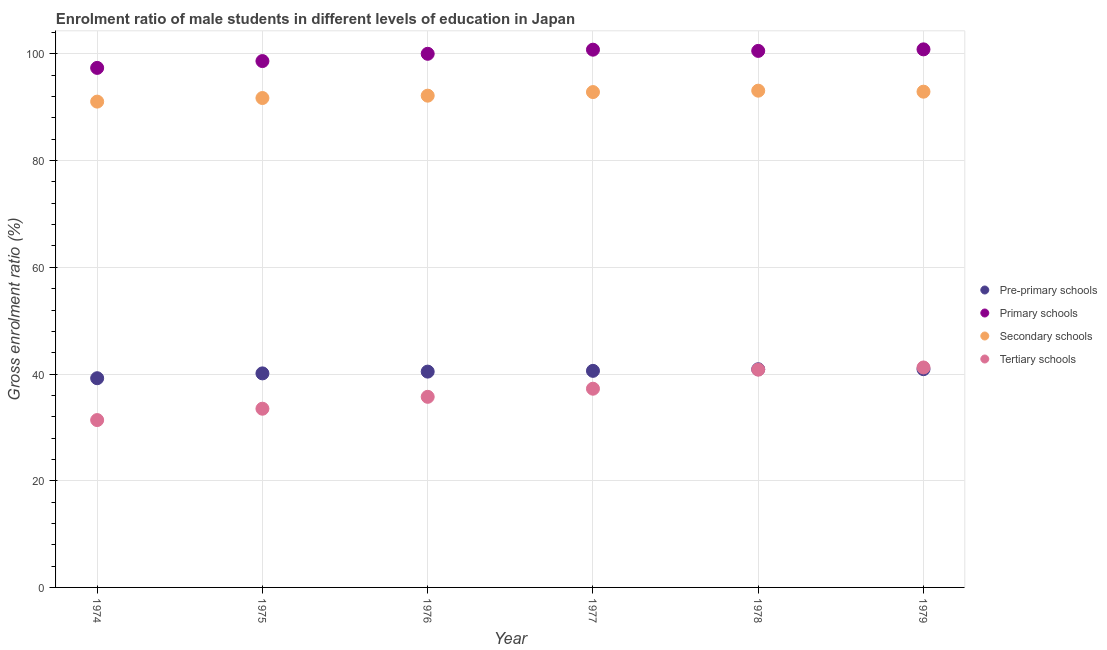Is the number of dotlines equal to the number of legend labels?
Your response must be concise. Yes. What is the gross enrolment ratio(female) in pre-primary schools in 1979?
Provide a succinct answer. 40.91. Across all years, what is the maximum gross enrolment ratio(female) in secondary schools?
Give a very brief answer. 93.11. Across all years, what is the minimum gross enrolment ratio(female) in pre-primary schools?
Make the answer very short. 39.21. In which year was the gross enrolment ratio(female) in secondary schools maximum?
Keep it short and to the point. 1978. In which year was the gross enrolment ratio(female) in tertiary schools minimum?
Provide a succinct answer. 1974. What is the total gross enrolment ratio(female) in tertiary schools in the graph?
Offer a terse response. 219.89. What is the difference between the gross enrolment ratio(female) in pre-primary schools in 1977 and that in 1978?
Keep it short and to the point. -0.3. What is the difference between the gross enrolment ratio(female) in primary schools in 1979 and the gross enrolment ratio(female) in tertiary schools in 1976?
Offer a terse response. 65.13. What is the average gross enrolment ratio(female) in primary schools per year?
Make the answer very short. 99.71. In the year 1977, what is the difference between the gross enrolment ratio(female) in pre-primary schools and gross enrolment ratio(female) in primary schools?
Your response must be concise. -60.2. What is the ratio of the gross enrolment ratio(female) in secondary schools in 1977 to that in 1978?
Provide a short and direct response. 1. Is the difference between the gross enrolment ratio(female) in secondary schools in 1976 and 1978 greater than the difference between the gross enrolment ratio(female) in pre-primary schools in 1976 and 1978?
Your answer should be compact. No. What is the difference between the highest and the second highest gross enrolment ratio(female) in primary schools?
Offer a terse response. 0.06. What is the difference between the highest and the lowest gross enrolment ratio(female) in tertiary schools?
Provide a succinct answer. 9.86. In how many years, is the gross enrolment ratio(female) in secondary schools greater than the average gross enrolment ratio(female) in secondary schools taken over all years?
Give a very brief answer. 3. Is it the case that in every year, the sum of the gross enrolment ratio(female) in tertiary schools and gross enrolment ratio(female) in pre-primary schools is greater than the sum of gross enrolment ratio(female) in primary schools and gross enrolment ratio(female) in secondary schools?
Ensure brevity in your answer.  No. Is it the case that in every year, the sum of the gross enrolment ratio(female) in pre-primary schools and gross enrolment ratio(female) in primary schools is greater than the gross enrolment ratio(female) in secondary schools?
Your answer should be compact. Yes. Is the gross enrolment ratio(female) in pre-primary schools strictly greater than the gross enrolment ratio(female) in primary schools over the years?
Your answer should be compact. No. Is the gross enrolment ratio(female) in pre-primary schools strictly less than the gross enrolment ratio(female) in tertiary schools over the years?
Your answer should be compact. No. How many years are there in the graph?
Your answer should be very brief. 6. What is the difference between two consecutive major ticks on the Y-axis?
Make the answer very short. 20. Are the values on the major ticks of Y-axis written in scientific E-notation?
Offer a terse response. No. Does the graph contain grids?
Provide a succinct answer. Yes. Where does the legend appear in the graph?
Make the answer very short. Center right. What is the title of the graph?
Your answer should be very brief. Enrolment ratio of male students in different levels of education in Japan. Does "Korea" appear as one of the legend labels in the graph?
Offer a very short reply. No. What is the Gross enrolment ratio (%) of Pre-primary schools in 1974?
Offer a terse response. 39.21. What is the Gross enrolment ratio (%) of Primary schools in 1974?
Provide a short and direct response. 97.38. What is the Gross enrolment ratio (%) of Secondary schools in 1974?
Give a very brief answer. 91.06. What is the Gross enrolment ratio (%) in Tertiary schools in 1974?
Offer a very short reply. 31.37. What is the Gross enrolment ratio (%) in Pre-primary schools in 1975?
Give a very brief answer. 40.12. What is the Gross enrolment ratio (%) of Primary schools in 1975?
Your answer should be compact. 98.66. What is the Gross enrolment ratio (%) in Secondary schools in 1975?
Offer a terse response. 91.73. What is the Gross enrolment ratio (%) in Tertiary schools in 1975?
Offer a very short reply. 33.5. What is the Gross enrolment ratio (%) of Pre-primary schools in 1976?
Provide a succinct answer. 40.45. What is the Gross enrolment ratio (%) of Primary schools in 1976?
Offer a terse response. 100.02. What is the Gross enrolment ratio (%) in Secondary schools in 1976?
Keep it short and to the point. 92.18. What is the Gross enrolment ratio (%) of Tertiary schools in 1976?
Keep it short and to the point. 35.73. What is the Gross enrolment ratio (%) of Pre-primary schools in 1977?
Give a very brief answer. 40.59. What is the Gross enrolment ratio (%) of Primary schools in 1977?
Your response must be concise. 100.8. What is the Gross enrolment ratio (%) of Secondary schools in 1977?
Make the answer very short. 92.85. What is the Gross enrolment ratio (%) in Tertiary schools in 1977?
Provide a short and direct response. 37.25. What is the Gross enrolment ratio (%) of Pre-primary schools in 1978?
Give a very brief answer. 40.89. What is the Gross enrolment ratio (%) in Primary schools in 1978?
Provide a short and direct response. 100.57. What is the Gross enrolment ratio (%) of Secondary schools in 1978?
Offer a very short reply. 93.11. What is the Gross enrolment ratio (%) in Tertiary schools in 1978?
Keep it short and to the point. 40.82. What is the Gross enrolment ratio (%) of Pre-primary schools in 1979?
Keep it short and to the point. 40.91. What is the Gross enrolment ratio (%) of Primary schools in 1979?
Offer a terse response. 100.86. What is the Gross enrolment ratio (%) of Secondary schools in 1979?
Your answer should be very brief. 92.92. What is the Gross enrolment ratio (%) of Tertiary schools in 1979?
Your answer should be very brief. 41.23. Across all years, what is the maximum Gross enrolment ratio (%) of Pre-primary schools?
Give a very brief answer. 40.91. Across all years, what is the maximum Gross enrolment ratio (%) in Primary schools?
Your answer should be compact. 100.86. Across all years, what is the maximum Gross enrolment ratio (%) of Secondary schools?
Your response must be concise. 93.11. Across all years, what is the maximum Gross enrolment ratio (%) in Tertiary schools?
Provide a succinct answer. 41.23. Across all years, what is the minimum Gross enrolment ratio (%) of Pre-primary schools?
Provide a succinct answer. 39.21. Across all years, what is the minimum Gross enrolment ratio (%) in Primary schools?
Give a very brief answer. 97.38. Across all years, what is the minimum Gross enrolment ratio (%) in Secondary schools?
Your answer should be compact. 91.06. Across all years, what is the minimum Gross enrolment ratio (%) in Tertiary schools?
Provide a succinct answer. 31.37. What is the total Gross enrolment ratio (%) in Pre-primary schools in the graph?
Provide a short and direct response. 242.18. What is the total Gross enrolment ratio (%) of Primary schools in the graph?
Offer a terse response. 598.28. What is the total Gross enrolment ratio (%) in Secondary schools in the graph?
Provide a short and direct response. 553.86. What is the total Gross enrolment ratio (%) in Tertiary schools in the graph?
Offer a terse response. 219.89. What is the difference between the Gross enrolment ratio (%) of Pre-primary schools in 1974 and that in 1975?
Offer a terse response. -0.91. What is the difference between the Gross enrolment ratio (%) of Primary schools in 1974 and that in 1975?
Make the answer very short. -1.28. What is the difference between the Gross enrolment ratio (%) of Secondary schools in 1974 and that in 1975?
Offer a very short reply. -0.67. What is the difference between the Gross enrolment ratio (%) of Tertiary schools in 1974 and that in 1975?
Make the answer very short. -2.13. What is the difference between the Gross enrolment ratio (%) of Pre-primary schools in 1974 and that in 1976?
Ensure brevity in your answer.  -1.24. What is the difference between the Gross enrolment ratio (%) in Primary schools in 1974 and that in 1976?
Your response must be concise. -2.64. What is the difference between the Gross enrolment ratio (%) in Secondary schools in 1974 and that in 1976?
Your answer should be very brief. -1.11. What is the difference between the Gross enrolment ratio (%) in Tertiary schools in 1974 and that in 1976?
Ensure brevity in your answer.  -4.36. What is the difference between the Gross enrolment ratio (%) of Pre-primary schools in 1974 and that in 1977?
Keep it short and to the point. -1.38. What is the difference between the Gross enrolment ratio (%) of Primary schools in 1974 and that in 1977?
Give a very brief answer. -3.41. What is the difference between the Gross enrolment ratio (%) of Secondary schools in 1974 and that in 1977?
Your answer should be compact. -1.79. What is the difference between the Gross enrolment ratio (%) of Tertiary schools in 1974 and that in 1977?
Provide a short and direct response. -5.88. What is the difference between the Gross enrolment ratio (%) in Pre-primary schools in 1974 and that in 1978?
Give a very brief answer. -1.68. What is the difference between the Gross enrolment ratio (%) of Primary schools in 1974 and that in 1978?
Your answer should be compact. -3.19. What is the difference between the Gross enrolment ratio (%) of Secondary schools in 1974 and that in 1978?
Give a very brief answer. -2.05. What is the difference between the Gross enrolment ratio (%) of Tertiary schools in 1974 and that in 1978?
Keep it short and to the point. -9.45. What is the difference between the Gross enrolment ratio (%) in Pre-primary schools in 1974 and that in 1979?
Give a very brief answer. -1.7. What is the difference between the Gross enrolment ratio (%) of Primary schools in 1974 and that in 1979?
Offer a very short reply. -3.47. What is the difference between the Gross enrolment ratio (%) in Secondary schools in 1974 and that in 1979?
Ensure brevity in your answer.  -1.86. What is the difference between the Gross enrolment ratio (%) in Tertiary schools in 1974 and that in 1979?
Offer a very short reply. -9.86. What is the difference between the Gross enrolment ratio (%) of Primary schools in 1975 and that in 1976?
Offer a terse response. -1.36. What is the difference between the Gross enrolment ratio (%) in Secondary schools in 1975 and that in 1976?
Your answer should be very brief. -0.44. What is the difference between the Gross enrolment ratio (%) of Tertiary schools in 1975 and that in 1976?
Provide a succinct answer. -2.23. What is the difference between the Gross enrolment ratio (%) of Pre-primary schools in 1975 and that in 1977?
Make the answer very short. -0.47. What is the difference between the Gross enrolment ratio (%) of Primary schools in 1975 and that in 1977?
Offer a very short reply. -2.14. What is the difference between the Gross enrolment ratio (%) in Secondary schools in 1975 and that in 1977?
Your answer should be very brief. -1.12. What is the difference between the Gross enrolment ratio (%) of Tertiary schools in 1975 and that in 1977?
Make the answer very short. -3.75. What is the difference between the Gross enrolment ratio (%) in Pre-primary schools in 1975 and that in 1978?
Your answer should be very brief. -0.77. What is the difference between the Gross enrolment ratio (%) in Primary schools in 1975 and that in 1978?
Make the answer very short. -1.91. What is the difference between the Gross enrolment ratio (%) in Secondary schools in 1975 and that in 1978?
Provide a short and direct response. -1.38. What is the difference between the Gross enrolment ratio (%) of Tertiary schools in 1975 and that in 1978?
Offer a terse response. -7.32. What is the difference between the Gross enrolment ratio (%) of Pre-primary schools in 1975 and that in 1979?
Your answer should be compact. -0.79. What is the difference between the Gross enrolment ratio (%) in Primary schools in 1975 and that in 1979?
Offer a very short reply. -2.2. What is the difference between the Gross enrolment ratio (%) of Secondary schools in 1975 and that in 1979?
Your answer should be very brief. -1.19. What is the difference between the Gross enrolment ratio (%) of Tertiary schools in 1975 and that in 1979?
Offer a terse response. -7.73. What is the difference between the Gross enrolment ratio (%) of Pre-primary schools in 1976 and that in 1977?
Offer a very short reply. -0.14. What is the difference between the Gross enrolment ratio (%) in Primary schools in 1976 and that in 1977?
Give a very brief answer. -0.77. What is the difference between the Gross enrolment ratio (%) of Secondary schools in 1976 and that in 1977?
Your answer should be very brief. -0.67. What is the difference between the Gross enrolment ratio (%) in Tertiary schools in 1976 and that in 1977?
Your answer should be compact. -1.52. What is the difference between the Gross enrolment ratio (%) in Pre-primary schools in 1976 and that in 1978?
Provide a short and direct response. -0.44. What is the difference between the Gross enrolment ratio (%) in Primary schools in 1976 and that in 1978?
Ensure brevity in your answer.  -0.54. What is the difference between the Gross enrolment ratio (%) of Secondary schools in 1976 and that in 1978?
Provide a short and direct response. -0.94. What is the difference between the Gross enrolment ratio (%) in Tertiary schools in 1976 and that in 1978?
Your answer should be compact. -5.09. What is the difference between the Gross enrolment ratio (%) of Pre-primary schools in 1976 and that in 1979?
Your response must be concise. -0.46. What is the difference between the Gross enrolment ratio (%) in Primary schools in 1976 and that in 1979?
Offer a very short reply. -0.83. What is the difference between the Gross enrolment ratio (%) in Secondary schools in 1976 and that in 1979?
Keep it short and to the point. -0.75. What is the difference between the Gross enrolment ratio (%) of Tertiary schools in 1976 and that in 1979?
Provide a short and direct response. -5.5. What is the difference between the Gross enrolment ratio (%) of Pre-primary schools in 1977 and that in 1978?
Your response must be concise. -0.3. What is the difference between the Gross enrolment ratio (%) of Primary schools in 1977 and that in 1978?
Keep it short and to the point. 0.23. What is the difference between the Gross enrolment ratio (%) in Secondary schools in 1977 and that in 1978?
Offer a terse response. -0.26. What is the difference between the Gross enrolment ratio (%) in Tertiary schools in 1977 and that in 1978?
Make the answer very short. -3.57. What is the difference between the Gross enrolment ratio (%) of Pre-primary schools in 1977 and that in 1979?
Offer a very short reply. -0.32. What is the difference between the Gross enrolment ratio (%) of Primary schools in 1977 and that in 1979?
Your answer should be very brief. -0.06. What is the difference between the Gross enrolment ratio (%) of Secondary schools in 1977 and that in 1979?
Your answer should be compact. -0.07. What is the difference between the Gross enrolment ratio (%) of Tertiary schools in 1977 and that in 1979?
Keep it short and to the point. -3.98. What is the difference between the Gross enrolment ratio (%) in Pre-primary schools in 1978 and that in 1979?
Ensure brevity in your answer.  -0.02. What is the difference between the Gross enrolment ratio (%) in Primary schools in 1978 and that in 1979?
Your response must be concise. -0.29. What is the difference between the Gross enrolment ratio (%) in Secondary schools in 1978 and that in 1979?
Ensure brevity in your answer.  0.19. What is the difference between the Gross enrolment ratio (%) of Tertiary schools in 1978 and that in 1979?
Your response must be concise. -0.41. What is the difference between the Gross enrolment ratio (%) in Pre-primary schools in 1974 and the Gross enrolment ratio (%) in Primary schools in 1975?
Your answer should be compact. -59.45. What is the difference between the Gross enrolment ratio (%) in Pre-primary schools in 1974 and the Gross enrolment ratio (%) in Secondary schools in 1975?
Provide a short and direct response. -52.52. What is the difference between the Gross enrolment ratio (%) of Pre-primary schools in 1974 and the Gross enrolment ratio (%) of Tertiary schools in 1975?
Give a very brief answer. 5.72. What is the difference between the Gross enrolment ratio (%) in Primary schools in 1974 and the Gross enrolment ratio (%) in Secondary schools in 1975?
Ensure brevity in your answer.  5.65. What is the difference between the Gross enrolment ratio (%) in Primary schools in 1974 and the Gross enrolment ratio (%) in Tertiary schools in 1975?
Provide a short and direct response. 63.88. What is the difference between the Gross enrolment ratio (%) of Secondary schools in 1974 and the Gross enrolment ratio (%) of Tertiary schools in 1975?
Your response must be concise. 57.56. What is the difference between the Gross enrolment ratio (%) in Pre-primary schools in 1974 and the Gross enrolment ratio (%) in Primary schools in 1976?
Your answer should be very brief. -60.81. What is the difference between the Gross enrolment ratio (%) in Pre-primary schools in 1974 and the Gross enrolment ratio (%) in Secondary schools in 1976?
Keep it short and to the point. -52.96. What is the difference between the Gross enrolment ratio (%) of Pre-primary schools in 1974 and the Gross enrolment ratio (%) of Tertiary schools in 1976?
Your response must be concise. 3.49. What is the difference between the Gross enrolment ratio (%) of Primary schools in 1974 and the Gross enrolment ratio (%) of Secondary schools in 1976?
Make the answer very short. 5.21. What is the difference between the Gross enrolment ratio (%) of Primary schools in 1974 and the Gross enrolment ratio (%) of Tertiary schools in 1976?
Offer a very short reply. 61.65. What is the difference between the Gross enrolment ratio (%) in Secondary schools in 1974 and the Gross enrolment ratio (%) in Tertiary schools in 1976?
Offer a very short reply. 55.33. What is the difference between the Gross enrolment ratio (%) of Pre-primary schools in 1974 and the Gross enrolment ratio (%) of Primary schools in 1977?
Your answer should be compact. -61.58. What is the difference between the Gross enrolment ratio (%) in Pre-primary schools in 1974 and the Gross enrolment ratio (%) in Secondary schools in 1977?
Keep it short and to the point. -53.64. What is the difference between the Gross enrolment ratio (%) in Pre-primary schools in 1974 and the Gross enrolment ratio (%) in Tertiary schools in 1977?
Your answer should be very brief. 1.97. What is the difference between the Gross enrolment ratio (%) of Primary schools in 1974 and the Gross enrolment ratio (%) of Secondary schools in 1977?
Offer a terse response. 4.53. What is the difference between the Gross enrolment ratio (%) of Primary schools in 1974 and the Gross enrolment ratio (%) of Tertiary schools in 1977?
Provide a succinct answer. 60.13. What is the difference between the Gross enrolment ratio (%) in Secondary schools in 1974 and the Gross enrolment ratio (%) in Tertiary schools in 1977?
Your answer should be very brief. 53.81. What is the difference between the Gross enrolment ratio (%) of Pre-primary schools in 1974 and the Gross enrolment ratio (%) of Primary schools in 1978?
Your response must be concise. -61.35. What is the difference between the Gross enrolment ratio (%) in Pre-primary schools in 1974 and the Gross enrolment ratio (%) in Secondary schools in 1978?
Offer a terse response. -53.9. What is the difference between the Gross enrolment ratio (%) of Pre-primary schools in 1974 and the Gross enrolment ratio (%) of Tertiary schools in 1978?
Make the answer very short. -1.61. What is the difference between the Gross enrolment ratio (%) in Primary schools in 1974 and the Gross enrolment ratio (%) in Secondary schools in 1978?
Provide a short and direct response. 4.27. What is the difference between the Gross enrolment ratio (%) in Primary schools in 1974 and the Gross enrolment ratio (%) in Tertiary schools in 1978?
Provide a short and direct response. 56.56. What is the difference between the Gross enrolment ratio (%) of Secondary schools in 1974 and the Gross enrolment ratio (%) of Tertiary schools in 1978?
Provide a short and direct response. 50.24. What is the difference between the Gross enrolment ratio (%) of Pre-primary schools in 1974 and the Gross enrolment ratio (%) of Primary schools in 1979?
Offer a very short reply. -61.64. What is the difference between the Gross enrolment ratio (%) in Pre-primary schools in 1974 and the Gross enrolment ratio (%) in Secondary schools in 1979?
Provide a short and direct response. -53.71. What is the difference between the Gross enrolment ratio (%) in Pre-primary schools in 1974 and the Gross enrolment ratio (%) in Tertiary schools in 1979?
Provide a succinct answer. -2.01. What is the difference between the Gross enrolment ratio (%) in Primary schools in 1974 and the Gross enrolment ratio (%) in Secondary schools in 1979?
Ensure brevity in your answer.  4.46. What is the difference between the Gross enrolment ratio (%) in Primary schools in 1974 and the Gross enrolment ratio (%) in Tertiary schools in 1979?
Your response must be concise. 56.15. What is the difference between the Gross enrolment ratio (%) in Secondary schools in 1974 and the Gross enrolment ratio (%) in Tertiary schools in 1979?
Keep it short and to the point. 49.83. What is the difference between the Gross enrolment ratio (%) in Pre-primary schools in 1975 and the Gross enrolment ratio (%) in Primary schools in 1976?
Your answer should be very brief. -59.9. What is the difference between the Gross enrolment ratio (%) of Pre-primary schools in 1975 and the Gross enrolment ratio (%) of Secondary schools in 1976?
Your response must be concise. -52.06. What is the difference between the Gross enrolment ratio (%) of Pre-primary schools in 1975 and the Gross enrolment ratio (%) of Tertiary schools in 1976?
Your response must be concise. 4.39. What is the difference between the Gross enrolment ratio (%) in Primary schools in 1975 and the Gross enrolment ratio (%) in Secondary schools in 1976?
Provide a short and direct response. 6.48. What is the difference between the Gross enrolment ratio (%) of Primary schools in 1975 and the Gross enrolment ratio (%) of Tertiary schools in 1976?
Your response must be concise. 62.93. What is the difference between the Gross enrolment ratio (%) of Secondary schools in 1975 and the Gross enrolment ratio (%) of Tertiary schools in 1976?
Provide a short and direct response. 56.01. What is the difference between the Gross enrolment ratio (%) of Pre-primary schools in 1975 and the Gross enrolment ratio (%) of Primary schools in 1977?
Keep it short and to the point. -60.68. What is the difference between the Gross enrolment ratio (%) in Pre-primary schools in 1975 and the Gross enrolment ratio (%) in Secondary schools in 1977?
Provide a short and direct response. -52.73. What is the difference between the Gross enrolment ratio (%) in Pre-primary schools in 1975 and the Gross enrolment ratio (%) in Tertiary schools in 1977?
Keep it short and to the point. 2.87. What is the difference between the Gross enrolment ratio (%) in Primary schools in 1975 and the Gross enrolment ratio (%) in Secondary schools in 1977?
Give a very brief answer. 5.81. What is the difference between the Gross enrolment ratio (%) of Primary schools in 1975 and the Gross enrolment ratio (%) of Tertiary schools in 1977?
Give a very brief answer. 61.41. What is the difference between the Gross enrolment ratio (%) of Secondary schools in 1975 and the Gross enrolment ratio (%) of Tertiary schools in 1977?
Offer a terse response. 54.49. What is the difference between the Gross enrolment ratio (%) in Pre-primary schools in 1975 and the Gross enrolment ratio (%) in Primary schools in 1978?
Make the answer very short. -60.45. What is the difference between the Gross enrolment ratio (%) in Pre-primary schools in 1975 and the Gross enrolment ratio (%) in Secondary schools in 1978?
Offer a terse response. -52.99. What is the difference between the Gross enrolment ratio (%) in Pre-primary schools in 1975 and the Gross enrolment ratio (%) in Tertiary schools in 1978?
Ensure brevity in your answer.  -0.7. What is the difference between the Gross enrolment ratio (%) of Primary schools in 1975 and the Gross enrolment ratio (%) of Secondary schools in 1978?
Offer a terse response. 5.55. What is the difference between the Gross enrolment ratio (%) in Primary schools in 1975 and the Gross enrolment ratio (%) in Tertiary schools in 1978?
Provide a succinct answer. 57.84. What is the difference between the Gross enrolment ratio (%) of Secondary schools in 1975 and the Gross enrolment ratio (%) of Tertiary schools in 1978?
Provide a short and direct response. 50.91. What is the difference between the Gross enrolment ratio (%) of Pre-primary schools in 1975 and the Gross enrolment ratio (%) of Primary schools in 1979?
Keep it short and to the point. -60.74. What is the difference between the Gross enrolment ratio (%) in Pre-primary schools in 1975 and the Gross enrolment ratio (%) in Secondary schools in 1979?
Provide a short and direct response. -52.81. What is the difference between the Gross enrolment ratio (%) of Pre-primary schools in 1975 and the Gross enrolment ratio (%) of Tertiary schools in 1979?
Your answer should be compact. -1.11. What is the difference between the Gross enrolment ratio (%) in Primary schools in 1975 and the Gross enrolment ratio (%) in Secondary schools in 1979?
Keep it short and to the point. 5.74. What is the difference between the Gross enrolment ratio (%) of Primary schools in 1975 and the Gross enrolment ratio (%) of Tertiary schools in 1979?
Make the answer very short. 57.43. What is the difference between the Gross enrolment ratio (%) of Secondary schools in 1975 and the Gross enrolment ratio (%) of Tertiary schools in 1979?
Your answer should be compact. 50.51. What is the difference between the Gross enrolment ratio (%) in Pre-primary schools in 1976 and the Gross enrolment ratio (%) in Primary schools in 1977?
Offer a terse response. -60.34. What is the difference between the Gross enrolment ratio (%) in Pre-primary schools in 1976 and the Gross enrolment ratio (%) in Secondary schools in 1977?
Your answer should be compact. -52.4. What is the difference between the Gross enrolment ratio (%) in Pre-primary schools in 1976 and the Gross enrolment ratio (%) in Tertiary schools in 1977?
Offer a very short reply. 3.21. What is the difference between the Gross enrolment ratio (%) in Primary schools in 1976 and the Gross enrolment ratio (%) in Secondary schools in 1977?
Ensure brevity in your answer.  7.17. What is the difference between the Gross enrolment ratio (%) in Primary schools in 1976 and the Gross enrolment ratio (%) in Tertiary schools in 1977?
Your answer should be very brief. 62.78. What is the difference between the Gross enrolment ratio (%) of Secondary schools in 1976 and the Gross enrolment ratio (%) of Tertiary schools in 1977?
Your answer should be very brief. 54.93. What is the difference between the Gross enrolment ratio (%) of Pre-primary schools in 1976 and the Gross enrolment ratio (%) of Primary schools in 1978?
Make the answer very short. -60.11. What is the difference between the Gross enrolment ratio (%) in Pre-primary schools in 1976 and the Gross enrolment ratio (%) in Secondary schools in 1978?
Provide a short and direct response. -52.66. What is the difference between the Gross enrolment ratio (%) in Pre-primary schools in 1976 and the Gross enrolment ratio (%) in Tertiary schools in 1978?
Make the answer very short. -0.37. What is the difference between the Gross enrolment ratio (%) in Primary schools in 1976 and the Gross enrolment ratio (%) in Secondary schools in 1978?
Provide a short and direct response. 6.91. What is the difference between the Gross enrolment ratio (%) in Primary schools in 1976 and the Gross enrolment ratio (%) in Tertiary schools in 1978?
Your answer should be very brief. 59.2. What is the difference between the Gross enrolment ratio (%) of Secondary schools in 1976 and the Gross enrolment ratio (%) of Tertiary schools in 1978?
Ensure brevity in your answer.  51.35. What is the difference between the Gross enrolment ratio (%) of Pre-primary schools in 1976 and the Gross enrolment ratio (%) of Primary schools in 1979?
Keep it short and to the point. -60.4. What is the difference between the Gross enrolment ratio (%) in Pre-primary schools in 1976 and the Gross enrolment ratio (%) in Secondary schools in 1979?
Provide a succinct answer. -52.47. What is the difference between the Gross enrolment ratio (%) of Pre-primary schools in 1976 and the Gross enrolment ratio (%) of Tertiary schools in 1979?
Offer a terse response. -0.77. What is the difference between the Gross enrolment ratio (%) in Primary schools in 1976 and the Gross enrolment ratio (%) in Secondary schools in 1979?
Give a very brief answer. 7.1. What is the difference between the Gross enrolment ratio (%) of Primary schools in 1976 and the Gross enrolment ratio (%) of Tertiary schools in 1979?
Provide a short and direct response. 58.8. What is the difference between the Gross enrolment ratio (%) of Secondary schools in 1976 and the Gross enrolment ratio (%) of Tertiary schools in 1979?
Offer a terse response. 50.95. What is the difference between the Gross enrolment ratio (%) in Pre-primary schools in 1977 and the Gross enrolment ratio (%) in Primary schools in 1978?
Provide a short and direct response. -59.97. What is the difference between the Gross enrolment ratio (%) in Pre-primary schools in 1977 and the Gross enrolment ratio (%) in Secondary schools in 1978?
Your answer should be compact. -52.52. What is the difference between the Gross enrolment ratio (%) of Pre-primary schools in 1977 and the Gross enrolment ratio (%) of Tertiary schools in 1978?
Your answer should be very brief. -0.23. What is the difference between the Gross enrolment ratio (%) of Primary schools in 1977 and the Gross enrolment ratio (%) of Secondary schools in 1978?
Keep it short and to the point. 7.68. What is the difference between the Gross enrolment ratio (%) of Primary schools in 1977 and the Gross enrolment ratio (%) of Tertiary schools in 1978?
Your response must be concise. 59.97. What is the difference between the Gross enrolment ratio (%) of Secondary schools in 1977 and the Gross enrolment ratio (%) of Tertiary schools in 1978?
Give a very brief answer. 52.03. What is the difference between the Gross enrolment ratio (%) of Pre-primary schools in 1977 and the Gross enrolment ratio (%) of Primary schools in 1979?
Provide a short and direct response. -60.26. What is the difference between the Gross enrolment ratio (%) of Pre-primary schools in 1977 and the Gross enrolment ratio (%) of Secondary schools in 1979?
Your response must be concise. -52.33. What is the difference between the Gross enrolment ratio (%) of Pre-primary schools in 1977 and the Gross enrolment ratio (%) of Tertiary schools in 1979?
Provide a short and direct response. -0.63. What is the difference between the Gross enrolment ratio (%) of Primary schools in 1977 and the Gross enrolment ratio (%) of Secondary schools in 1979?
Give a very brief answer. 7.87. What is the difference between the Gross enrolment ratio (%) in Primary schools in 1977 and the Gross enrolment ratio (%) in Tertiary schools in 1979?
Offer a very short reply. 59.57. What is the difference between the Gross enrolment ratio (%) of Secondary schools in 1977 and the Gross enrolment ratio (%) of Tertiary schools in 1979?
Give a very brief answer. 51.62. What is the difference between the Gross enrolment ratio (%) of Pre-primary schools in 1978 and the Gross enrolment ratio (%) of Primary schools in 1979?
Offer a very short reply. -59.96. What is the difference between the Gross enrolment ratio (%) in Pre-primary schools in 1978 and the Gross enrolment ratio (%) in Secondary schools in 1979?
Provide a short and direct response. -52.03. What is the difference between the Gross enrolment ratio (%) of Pre-primary schools in 1978 and the Gross enrolment ratio (%) of Tertiary schools in 1979?
Keep it short and to the point. -0.33. What is the difference between the Gross enrolment ratio (%) in Primary schools in 1978 and the Gross enrolment ratio (%) in Secondary schools in 1979?
Your answer should be compact. 7.64. What is the difference between the Gross enrolment ratio (%) in Primary schools in 1978 and the Gross enrolment ratio (%) in Tertiary schools in 1979?
Your answer should be very brief. 59.34. What is the difference between the Gross enrolment ratio (%) of Secondary schools in 1978 and the Gross enrolment ratio (%) of Tertiary schools in 1979?
Keep it short and to the point. 51.88. What is the average Gross enrolment ratio (%) of Pre-primary schools per year?
Provide a succinct answer. 40.36. What is the average Gross enrolment ratio (%) of Primary schools per year?
Make the answer very short. 99.71. What is the average Gross enrolment ratio (%) in Secondary schools per year?
Give a very brief answer. 92.31. What is the average Gross enrolment ratio (%) in Tertiary schools per year?
Give a very brief answer. 36.65. In the year 1974, what is the difference between the Gross enrolment ratio (%) of Pre-primary schools and Gross enrolment ratio (%) of Primary schools?
Offer a very short reply. -58.17. In the year 1974, what is the difference between the Gross enrolment ratio (%) in Pre-primary schools and Gross enrolment ratio (%) in Secondary schools?
Make the answer very short. -51.85. In the year 1974, what is the difference between the Gross enrolment ratio (%) in Pre-primary schools and Gross enrolment ratio (%) in Tertiary schools?
Offer a very short reply. 7.84. In the year 1974, what is the difference between the Gross enrolment ratio (%) of Primary schools and Gross enrolment ratio (%) of Secondary schools?
Give a very brief answer. 6.32. In the year 1974, what is the difference between the Gross enrolment ratio (%) in Primary schools and Gross enrolment ratio (%) in Tertiary schools?
Keep it short and to the point. 66.01. In the year 1974, what is the difference between the Gross enrolment ratio (%) of Secondary schools and Gross enrolment ratio (%) of Tertiary schools?
Give a very brief answer. 59.69. In the year 1975, what is the difference between the Gross enrolment ratio (%) of Pre-primary schools and Gross enrolment ratio (%) of Primary schools?
Your answer should be very brief. -58.54. In the year 1975, what is the difference between the Gross enrolment ratio (%) in Pre-primary schools and Gross enrolment ratio (%) in Secondary schools?
Offer a terse response. -51.61. In the year 1975, what is the difference between the Gross enrolment ratio (%) in Pre-primary schools and Gross enrolment ratio (%) in Tertiary schools?
Ensure brevity in your answer.  6.62. In the year 1975, what is the difference between the Gross enrolment ratio (%) in Primary schools and Gross enrolment ratio (%) in Secondary schools?
Ensure brevity in your answer.  6.93. In the year 1975, what is the difference between the Gross enrolment ratio (%) of Primary schools and Gross enrolment ratio (%) of Tertiary schools?
Your answer should be very brief. 65.16. In the year 1975, what is the difference between the Gross enrolment ratio (%) of Secondary schools and Gross enrolment ratio (%) of Tertiary schools?
Your response must be concise. 58.24. In the year 1976, what is the difference between the Gross enrolment ratio (%) in Pre-primary schools and Gross enrolment ratio (%) in Primary schools?
Ensure brevity in your answer.  -59.57. In the year 1976, what is the difference between the Gross enrolment ratio (%) in Pre-primary schools and Gross enrolment ratio (%) in Secondary schools?
Provide a succinct answer. -51.72. In the year 1976, what is the difference between the Gross enrolment ratio (%) in Pre-primary schools and Gross enrolment ratio (%) in Tertiary schools?
Provide a succinct answer. 4.72. In the year 1976, what is the difference between the Gross enrolment ratio (%) of Primary schools and Gross enrolment ratio (%) of Secondary schools?
Provide a short and direct response. 7.85. In the year 1976, what is the difference between the Gross enrolment ratio (%) in Primary schools and Gross enrolment ratio (%) in Tertiary schools?
Your answer should be very brief. 64.3. In the year 1976, what is the difference between the Gross enrolment ratio (%) of Secondary schools and Gross enrolment ratio (%) of Tertiary schools?
Give a very brief answer. 56.45. In the year 1977, what is the difference between the Gross enrolment ratio (%) of Pre-primary schools and Gross enrolment ratio (%) of Primary schools?
Keep it short and to the point. -60.2. In the year 1977, what is the difference between the Gross enrolment ratio (%) of Pre-primary schools and Gross enrolment ratio (%) of Secondary schools?
Give a very brief answer. -52.26. In the year 1977, what is the difference between the Gross enrolment ratio (%) of Pre-primary schools and Gross enrolment ratio (%) of Tertiary schools?
Your answer should be compact. 3.35. In the year 1977, what is the difference between the Gross enrolment ratio (%) in Primary schools and Gross enrolment ratio (%) in Secondary schools?
Offer a very short reply. 7.95. In the year 1977, what is the difference between the Gross enrolment ratio (%) of Primary schools and Gross enrolment ratio (%) of Tertiary schools?
Your response must be concise. 63.55. In the year 1977, what is the difference between the Gross enrolment ratio (%) of Secondary schools and Gross enrolment ratio (%) of Tertiary schools?
Offer a very short reply. 55.6. In the year 1978, what is the difference between the Gross enrolment ratio (%) in Pre-primary schools and Gross enrolment ratio (%) in Primary schools?
Your answer should be compact. -59.67. In the year 1978, what is the difference between the Gross enrolment ratio (%) of Pre-primary schools and Gross enrolment ratio (%) of Secondary schools?
Make the answer very short. -52.22. In the year 1978, what is the difference between the Gross enrolment ratio (%) in Pre-primary schools and Gross enrolment ratio (%) in Tertiary schools?
Offer a terse response. 0.07. In the year 1978, what is the difference between the Gross enrolment ratio (%) of Primary schools and Gross enrolment ratio (%) of Secondary schools?
Your response must be concise. 7.46. In the year 1978, what is the difference between the Gross enrolment ratio (%) of Primary schools and Gross enrolment ratio (%) of Tertiary schools?
Offer a very short reply. 59.75. In the year 1978, what is the difference between the Gross enrolment ratio (%) in Secondary schools and Gross enrolment ratio (%) in Tertiary schools?
Provide a short and direct response. 52.29. In the year 1979, what is the difference between the Gross enrolment ratio (%) in Pre-primary schools and Gross enrolment ratio (%) in Primary schools?
Make the answer very short. -59.94. In the year 1979, what is the difference between the Gross enrolment ratio (%) of Pre-primary schools and Gross enrolment ratio (%) of Secondary schools?
Make the answer very short. -52.01. In the year 1979, what is the difference between the Gross enrolment ratio (%) of Pre-primary schools and Gross enrolment ratio (%) of Tertiary schools?
Provide a short and direct response. -0.32. In the year 1979, what is the difference between the Gross enrolment ratio (%) in Primary schools and Gross enrolment ratio (%) in Secondary schools?
Offer a terse response. 7.93. In the year 1979, what is the difference between the Gross enrolment ratio (%) of Primary schools and Gross enrolment ratio (%) of Tertiary schools?
Give a very brief answer. 59.63. In the year 1979, what is the difference between the Gross enrolment ratio (%) in Secondary schools and Gross enrolment ratio (%) in Tertiary schools?
Offer a very short reply. 51.7. What is the ratio of the Gross enrolment ratio (%) in Pre-primary schools in 1974 to that in 1975?
Your answer should be very brief. 0.98. What is the ratio of the Gross enrolment ratio (%) in Primary schools in 1974 to that in 1975?
Provide a succinct answer. 0.99. What is the ratio of the Gross enrolment ratio (%) of Secondary schools in 1974 to that in 1975?
Your answer should be very brief. 0.99. What is the ratio of the Gross enrolment ratio (%) in Tertiary schools in 1974 to that in 1975?
Offer a very short reply. 0.94. What is the ratio of the Gross enrolment ratio (%) of Pre-primary schools in 1974 to that in 1976?
Your answer should be very brief. 0.97. What is the ratio of the Gross enrolment ratio (%) in Primary schools in 1974 to that in 1976?
Keep it short and to the point. 0.97. What is the ratio of the Gross enrolment ratio (%) of Secondary schools in 1974 to that in 1976?
Provide a short and direct response. 0.99. What is the ratio of the Gross enrolment ratio (%) in Tertiary schools in 1974 to that in 1976?
Provide a short and direct response. 0.88. What is the ratio of the Gross enrolment ratio (%) of Primary schools in 1974 to that in 1977?
Give a very brief answer. 0.97. What is the ratio of the Gross enrolment ratio (%) in Secondary schools in 1974 to that in 1977?
Make the answer very short. 0.98. What is the ratio of the Gross enrolment ratio (%) of Tertiary schools in 1974 to that in 1977?
Your response must be concise. 0.84. What is the ratio of the Gross enrolment ratio (%) of Primary schools in 1974 to that in 1978?
Your answer should be compact. 0.97. What is the ratio of the Gross enrolment ratio (%) of Tertiary schools in 1974 to that in 1978?
Offer a very short reply. 0.77. What is the ratio of the Gross enrolment ratio (%) in Pre-primary schools in 1974 to that in 1979?
Your answer should be very brief. 0.96. What is the ratio of the Gross enrolment ratio (%) of Primary schools in 1974 to that in 1979?
Give a very brief answer. 0.97. What is the ratio of the Gross enrolment ratio (%) of Secondary schools in 1974 to that in 1979?
Offer a very short reply. 0.98. What is the ratio of the Gross enrolment ratio (%) in Tertiary schools in 1974 to that in 1979?
Your response must be concise. 0.76. What is the ratio of the Gross enrolment ratio (%) in Pre-primary schools in 1975 to that in 1976?
Provide a short and direct response. 0.99. What is the ratio of the Gross enrolment ratio (%) of Primary schools in 1975 to that in 1976?
Offer a very short reply. 0.99. What is the ratio of the Gross enrolment ratio (%) of Tertiary schools in 1975 to that in 1976?
Your answer should be compact. 0.94. What is the ratio of the Gross enrolment ratio (%) in Pre-primary schools in 1975 to that in 1977?
Offer a very short reply. 0.99. What is the ratio of the Gross enrolment ratio (%) in Primary schools in 1975 to that in 1977?
Your answer should be very brief. 0.98. What is the ratio of the Gross enrolment ratio (%) in Tertiary schools in 1975 to that in 1977?
Offer a very short reply. 0.9. What is the ratio of the Gross enrolment ratio (%) of Pre-primary schools in 1975 to that in 1978?
Make the answer very short. 0.98. What is the ratio of the Gross enrolment ratio (%) in Secondary schools in 1975 to that in 1978?
Offer a very short reply. 0.99. What is the ratio of the Gross enrolment ratio (%) in Tertiary schools in 1975 to that in 1978?
Ensure brevity in your answer.  0.82. What is the ratio of the Gross enrolment ratio (%) in Pre-primary schools in 1975 to that in 1979?
Your answer should be compact. 0.98. What is the ratio of the Gross enrolment ratio (%) of Primary schools in 1975 to that in 1979?
Offer a very short reply. 0.98. What is the ratio of the Gross enrolment ratio (%) of Secondary schools in 1975 to that in 1979?
Offer a very short reply. 0.99. What is the ratio of the Gross enrolment ratio (%) in Tertiary schools in 1975 to that in 1979?
Ensure brevity in your answer.  0.81. What is the ratio of the Gross enrolment ratio (%) of Pre-primary schools in 1976 to that in 1977?
Keep it short and to the point. 1. What is the ratio of the Gross enrolment ratio (%) of Primary schools in 1976 to that in 1977?
Your answer should be very brief. 0.99. What is the ratio of the Gross enrolment ratio (%) in Secondary schools in 1976 to that in 1977?
Keep it short and to the point. 0.99. What is the ratio of the Gross enrolment ratio (%) of Tertiary schools in 1976 to that in 1977?
Keep it short and to the point. 0.96. What is the ratio of the Gross enrolment ratio (%) in Primary schools in 1976 to that in 1978?
Keep it short and to the point. 0.99. What is the ratio of the Gross enrolment ratio (%) of Tertiary schools in 1976 to that in 1978?
Give a very brief answer. 0.88. What is the ratio of the Gross enrolment ratio (%) of Tertiary schools in 1976 to that in 1979?
Keep it short and to the point. 0.87. What is the ratio of the Gross enrolment ratio (%) in Tertiary schools in 1977 to that in 1978?
Your answer should be very brief. 0.91. What is the ratio of the Gross enrolment ratio (%) of Pre-primary schools in 1977 to that in 1979?
Provide a succinct answer. 0.99. What is the ratio of the Gross enrolment ratio (%) in Tertiary schools in 1977 to that in 1979?
Provide a succinct answer. 0.9. What is the ratio of the Gross enrolment ratio (%) of Pre-primary schools in 1978 to that in 1979?
Your response must be concise. 1. What is the ratio of the Gross enrolment ratio (%) of Secondary schools in 1978 to that in 1979?
Offer a very short reply. 1. What is the ratio of the Gross enrolment ratio (%) in Tertiary schools in 1978 to that in 1979?
Provide a succinct answer. 0.99. What is the difference between the highest and the second highest Gross enrolment ratio (%) of Pre-primary schools?
Your answer should be very brief. 0.02. What is the difference between the highest and the second highest Gross enrolment ratio (%) in Secondary schools?
Make the answer very short. 0.19. What is the difference between the highest and the second highest Gross enrolment ratio (%) of Tertiary schools?
Keep it short and to the point. 0.41. What is the difference between the highest and the lowest Gross enrolment ratio (%) of Pre-primary schools?
Your response must be concise. 1.7. What is the difference between the highest and the lowest Gross enrolment ratio (%) in Primary schools?
Provide a succinct answer. 3.47. What is the difference between the highest and the lowest Gross enrolment ratio (%) in Secondary schools?
Offer a terse response. 2.05. What is the difference between the highest and the lowest Gross enrolment ratio (%) of Tertiary schools?
Ensure brevity in your answer.  9.86. 